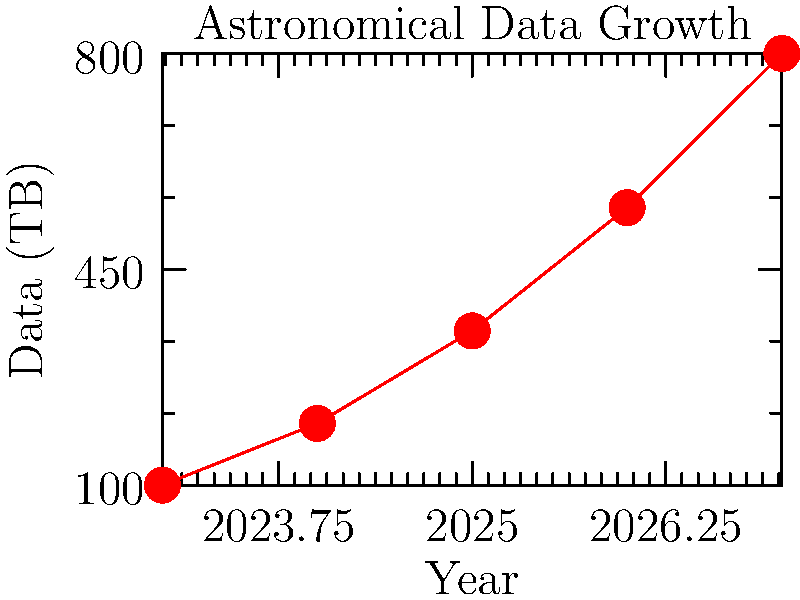Based on the graph showing astronomical data growth over time, if your organization needs to plan for storage capacity in 2028, and assuming the trend continues, approximately how many terabytes of storage should be allocated? Round your answer to the nearest 100 TB. To estimate the storage requirement for 2028, we need to:

1. Analyze the trend in the graph:
   - 2023: 100 TB
   - 2024: 200 TB
   - 2025: 350 TB
   - 2026: 550 TB
   - 2027: 800 TB

2. Calculate the year-over-year growth:
   - 2023 to 2024: 100 TB
   - 2024 to 2025: 150 TB
   - 2025 to 2026: 200 TB
   - 2026 to 2027: 250 TB

3. Observe that the growth is accelerating by about 50 TB each year:
   - 100 TB, then 150 TB, then 200 TB, then 250 TB

4. Project the growth for the next year (2027 to 2028):
   - Previous growth + 50 TB = 250 TB + 50 TB = 300 TB

5. Add this projected growth to the 2027 value:
   - 2028 estimate = 2027 value + projected growth
   - 2028 estimate = 800 TB + 300 TB = 1100 TB

6. Round to the nearest 100 TB:
   - 1100 TB rounds to 1100 TB

Therefore, the organization should plan for approximately 1100 TB of storage capacity for 2028.
Answer: 1100 TB 